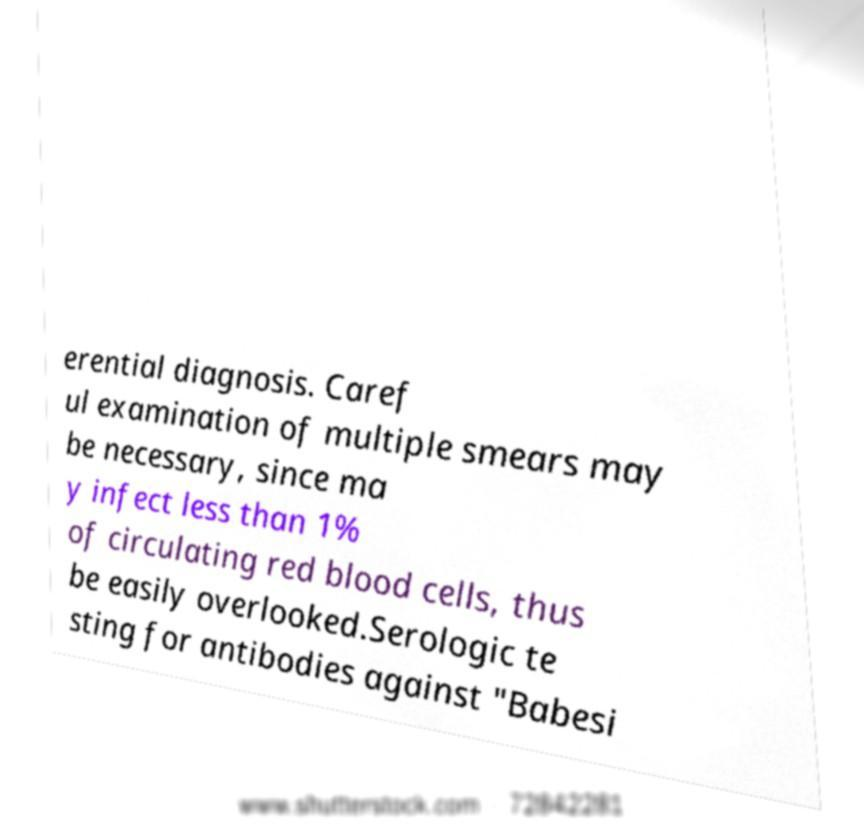Could you assist in decoding the text presented in this image and type it out clearly? erential diagnosis. Caref ul examination of multiple smears may be necessary, since ma y infect less than 1% of circulating red blood cells, thus be easily overlooked.Serologic te sting for antibodies against "Babesi 